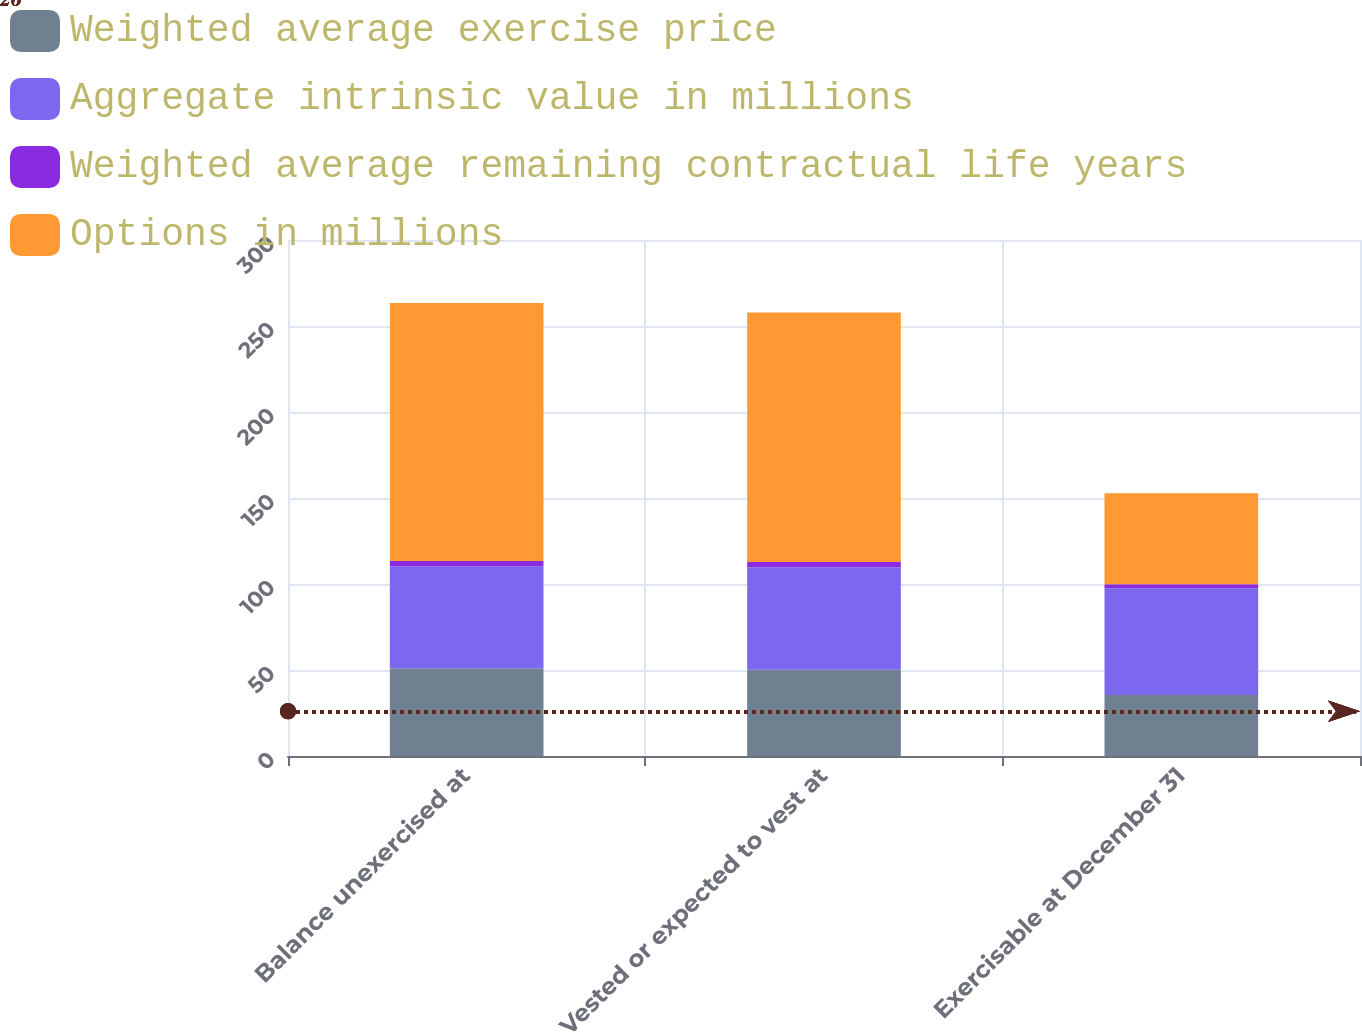Convert chart to OTSL. <chart><loc_0><loc_0><loc_500><loc_500><stacked_bar_chart><ecel><fcel>Balance unexercised at<fcel>Vested or expected to vest at<fcel>Exercisable at December 31<nl><fcel>Weighted average exercise price<fcel>50.8<fcel>50.1<fcel>35.4<nl><fcel>Aggregate intrinsic value in millions<fcel>59.5<fcel>59.64<fcel>62.2<nl><fcel>Weighted average remaining contractual life years<fcel>3.1<fcel>3.1<fcel>2.2<nl><fcel>Options in millions<fcel>150<fcel>145<fcel>53<nl></chart> 